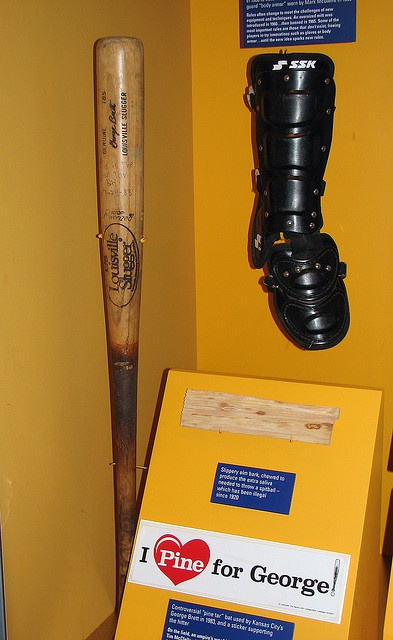Describe the objects in this image and their specific colors. I can see a baseball bat in olive, maroon, black, and tan tones in this image. 